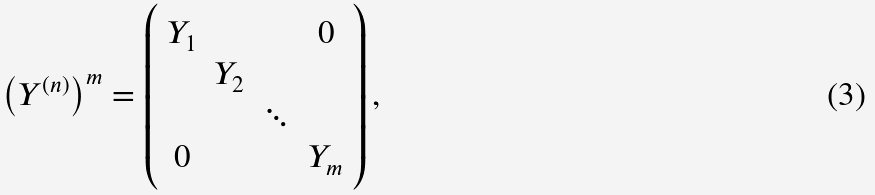Convert formula to latex. <formula><loc_0><loc_0><loc_500><loc_500>\left ( Y ^ { ( n ) } \right ) ^ { m } = \left ( \begin{array} { c c c c } Y _ { 1 } & & & 0 \\ & Y _ { 2 } & & \\ & & \ddots & \\ 0 & & & Y _ { m } \end{array} \right ) ,</formula> 